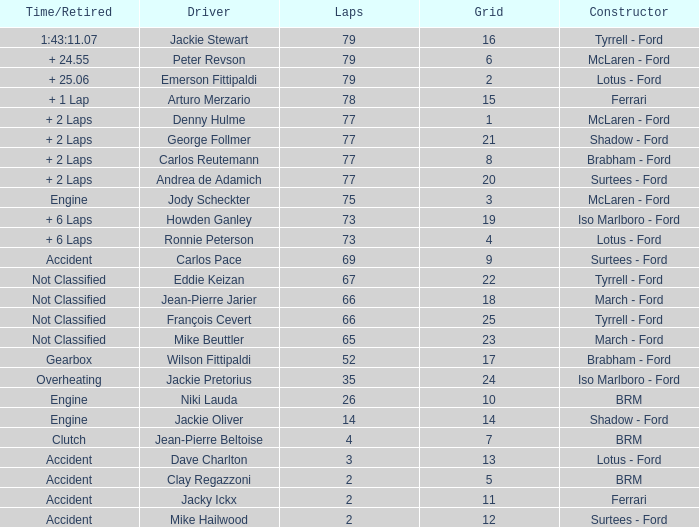How much time is required for less than 35 laps and less than 10 grids? Clutch, Accident. 